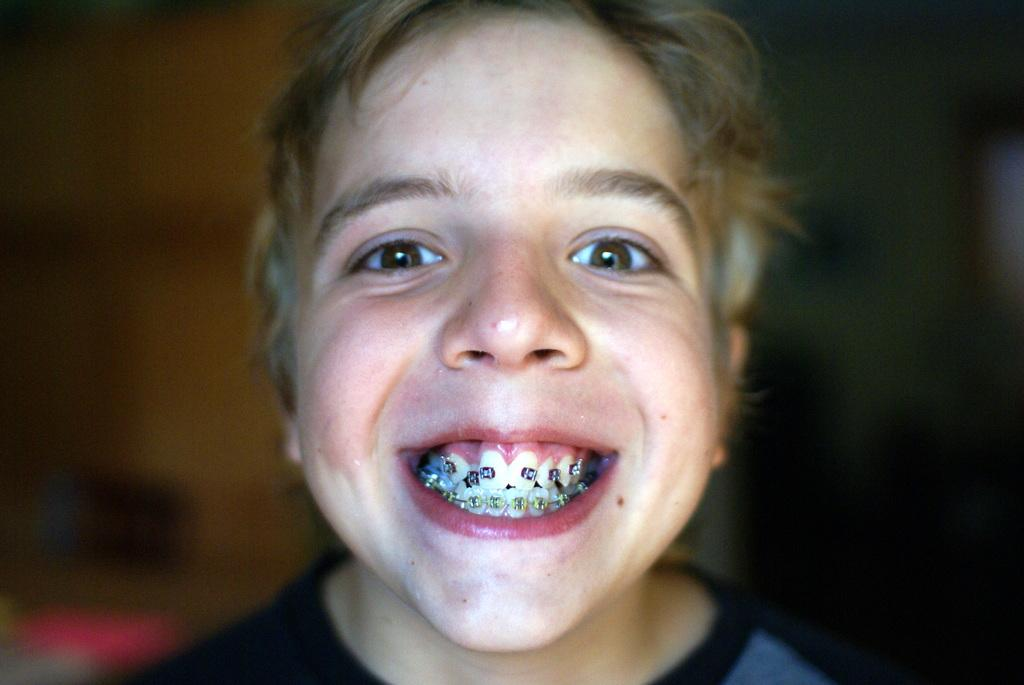What is the main subject of the image? The main subject of the image is a kid. What is the kid's expression in the image? The kid is smiling in the image. How would you describe the background of the image? The background of the image is blurry. What type of meat is being sold in the shop in the image? There is no shop or meat present in the image; it features a kid who is smiling. How many carts are visible in the image? There are no carts present in the image. 